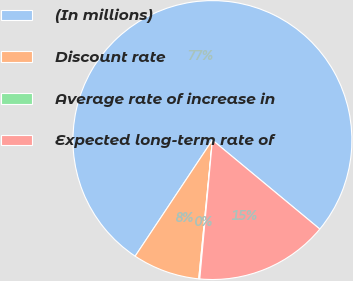Convert chart. <chart><loc_0><loc_0><loc_500><loc_500><pie_chart><fcel>(In millions)<fcel>Discount rate<fcel>Average rate of increase in<fcel>Expected long-term rate of<nl><fcel>76.67%<fcel>7.78%<fcel>0.12%<fcel>15.43%<nl></chart> 